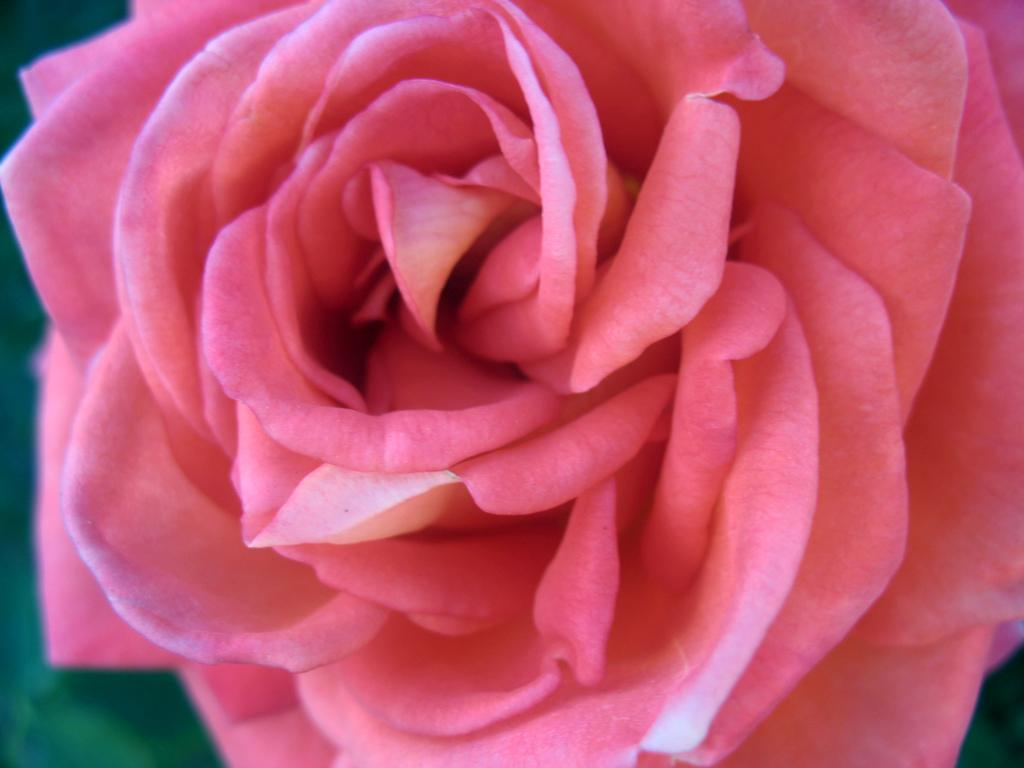What color is the background of the image? The background of the image is green. What can be found in the middle of the image? There is a pink rose in the middle of the image. Is there a woman holding the pink rose in the image? There is no woman present in the image; only the pink rose can be seen. What type of event is taking place in the image? There is no event depicted in the image; it simply features a pink rose in a green background. 